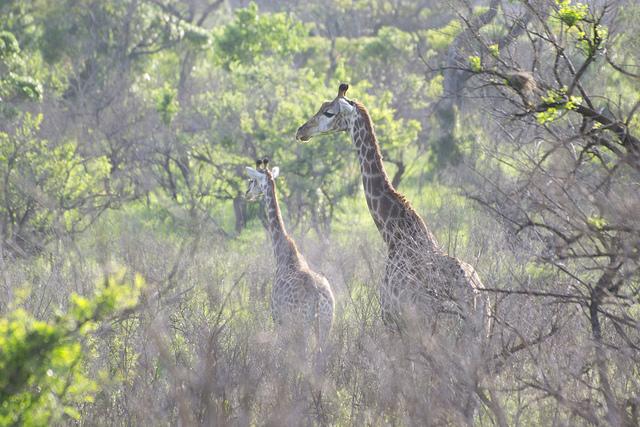Are the giraffe's running?
Quick response, please. No. Are these animals hunted?
Keep it brief. No. Where are the giraffe looking at?
Concise answer only. Left. 